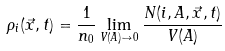<formula> <loc_0><loc_0><loc_500><loc_500>\rho _ { i } ( \vec { x } , t ) = \frac { 1 } { n _ { 0 } } \lim _ { V ( A ) \to 0 } \frac { N ( i , A , \vec { x } , t ) } { V ( A ) }</formula> 